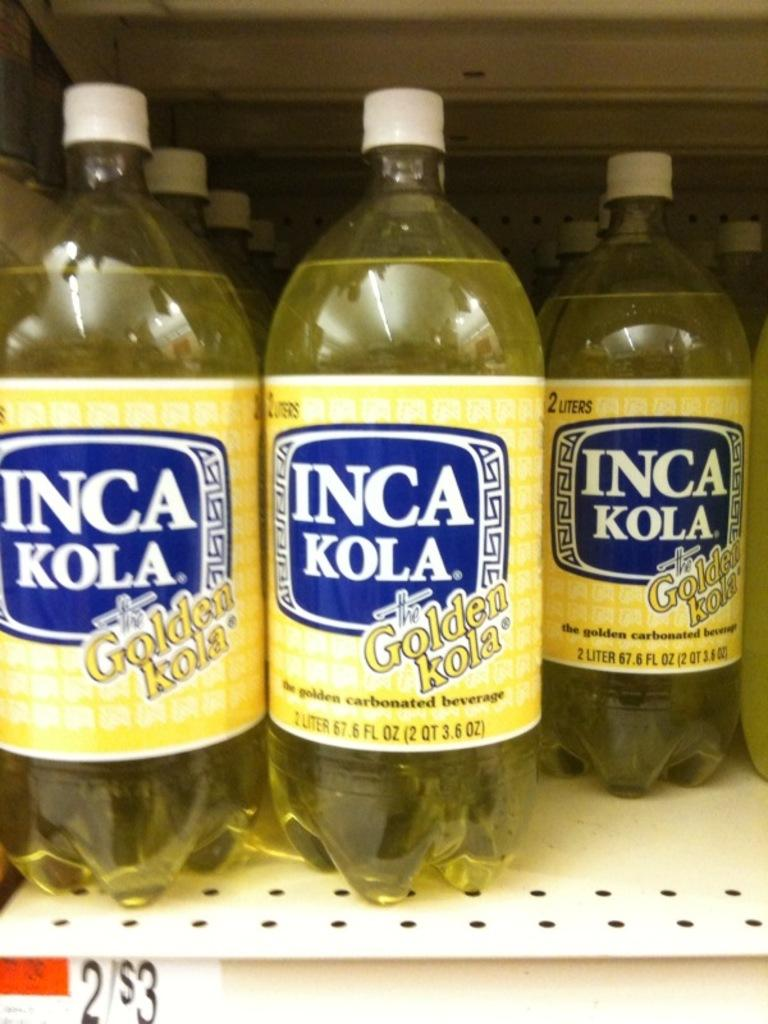<image>
Write a terse but informative summary of the picture. Inca Kola bottles are organized on a shelf 